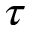<formula> <loc_0><loc_0><loc_500><loc_500>\tau</formula> 